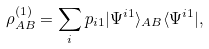Convert formula to latex. <formula><loc_0><loc_0><loc_500><loc_500>\rho ^ { ( 1 ) } _ { A B } = \sum _ { i } p _ { i 1 } | \Psi ^ { i 1 } \rangle _ { A B } \langle \Psi ^ { i 1 } | ,</formula> 